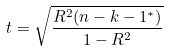<formula> <loc_0><loc_0><loc_500><loc_500>t = { \sqrt { \frac { R ^ { 2 } ( n - k - 1 ^ { * } ) } { 1 - R ^ { 2 } } } }</formula> 